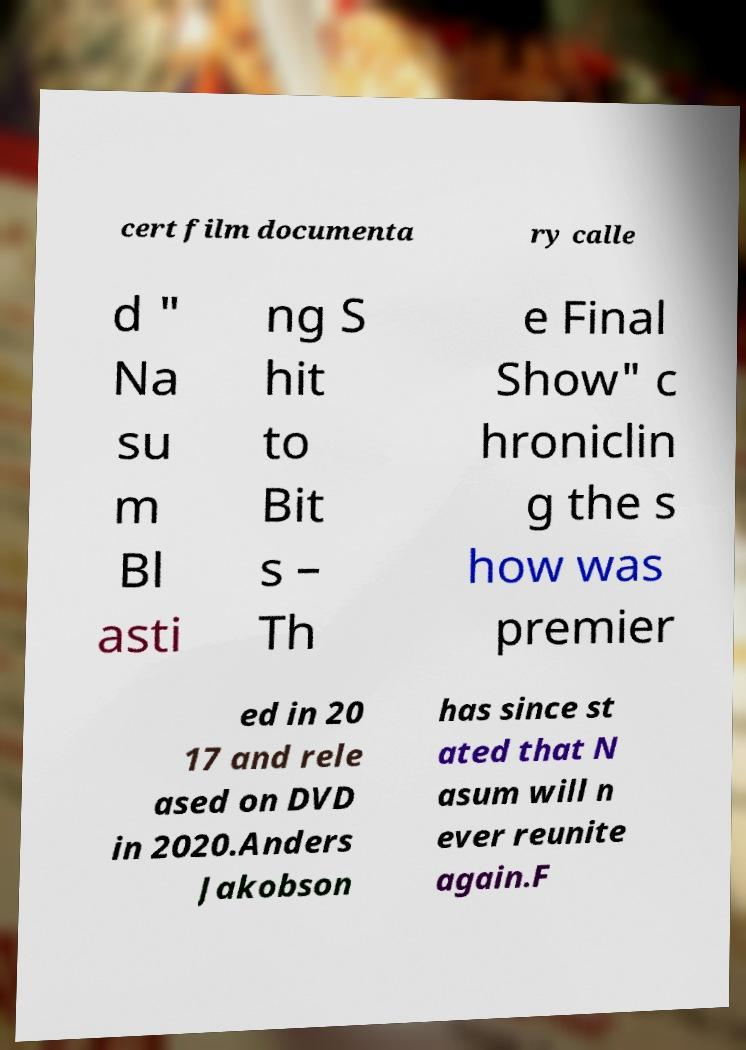Can you read and provide the text displayed in the image?This photo seems to have some interesting text. Can you extract and type it out for me? cert film documenta ry calle d " Na su m Bl asti ng S hit to Bit s – Th e Final Show" c hroniclin g the s how was premier ed in 20 17 and rele ased on DVD in 2020.Anders Jakobson has since st ated that N asum will n ever reunite again.F 